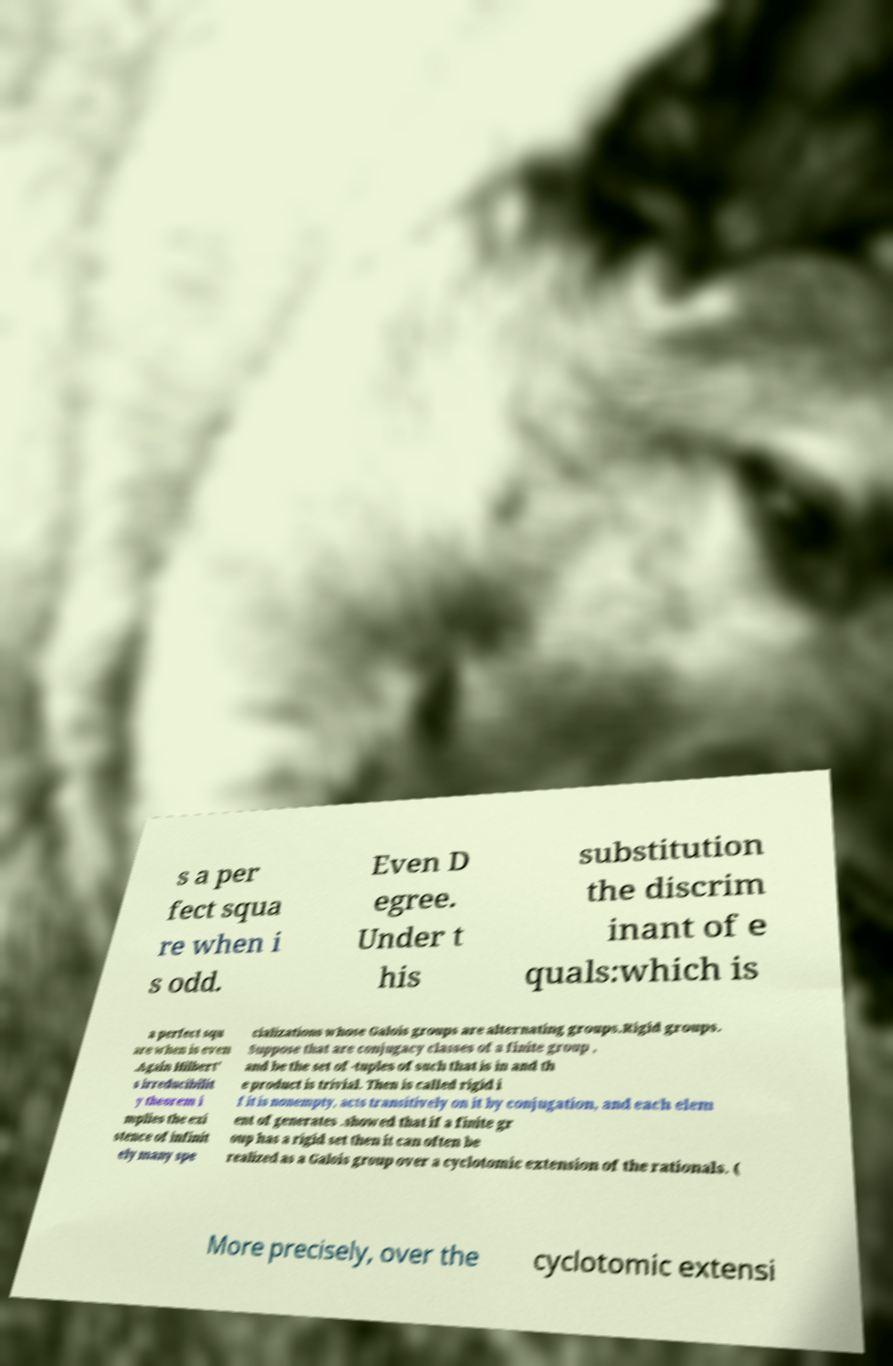Can you read and provide the text displayed in the image?This photo seems to have some interesting text. Can you extract and type it out for me? s a per fect squa re when i s odd. Even D egree. Under t his substitution the discrim inant of e quals:which is a perfect squ are when is even .Again Hilbert' s irreducibilit y theorem i mplies the exi stence of infinit ely many spe cializations whose Galois groups are alternating groups.Rigid groups. Suppose that are conjugacy classes of a finite group , and be the set of -tuples of such that is in and th e product is trivial. Then is called rigid i f it is nonempty, acts transitively on it by conjugation, and each elem ent of generates .showed that if a finite gr oup has a rigid set then it can often be realized as a Galois group over a cyclotomic extension of the rationals. ( More precisely, over the cyclotomic extensi 